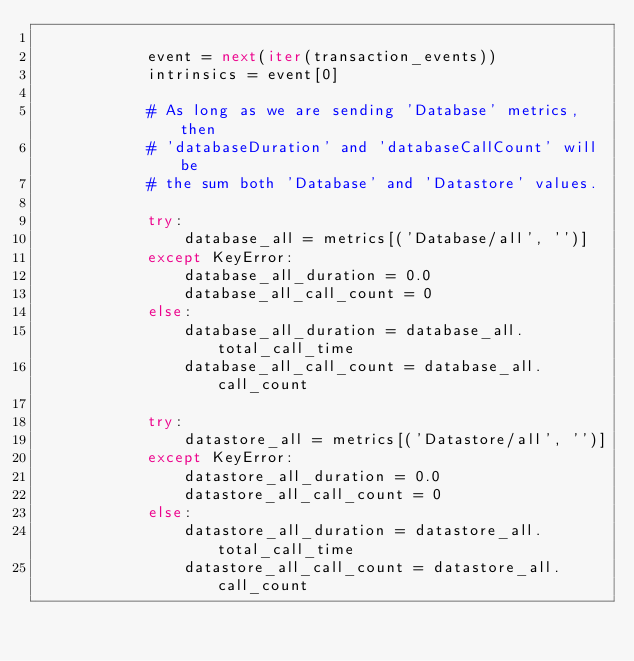Convert code to text. <code><loc_0><loc_0><loc_500><loc_500><_Python_>
            event = next(iter(transaction_events))
            intrinsics = event[0]

            # As long as we are sending 'Database' metrics, then
            # 'databaseDuration' and 'databaseCallCount' will be
            # the sum both 'Database' and 'Datastore' values.

            try:
                database_all = metrics[('Database/all', '')]
            except KeyError:
                database_all_duration = 0.0
                database_all_call_count = 0
            else:
                database_all_duration = database_all.total_call_time
                database_all_call_count = database_all.call_count

            try:
                datastore_all = metrics[('Datastore/all', '')]
            except KeyError:
                datastore_all_duration = 0.0
                datastore_all_call_count = 0
            else:
                datastore_all_duration = datastore_all.total_call_time
                datastore_all_call_count = datastore_all.call_count
</code> 